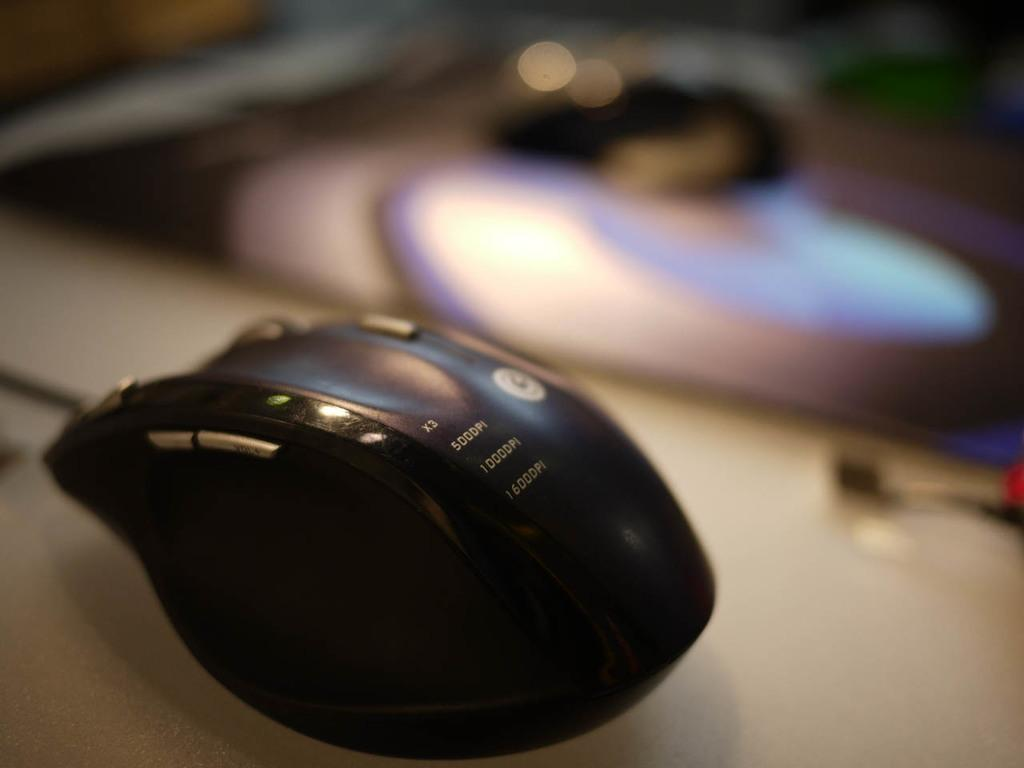What piece of furniture is present in the image? There is a desk in the image. What object is on the desk? There is a black mouse on the desk. Can you describe the background of the image? The background of the image is not visible or described in the provided facts. Where is the mom of the rabbits in the image? There are no rabbits or mom mentioned in the image, so we cannot answer this question. 